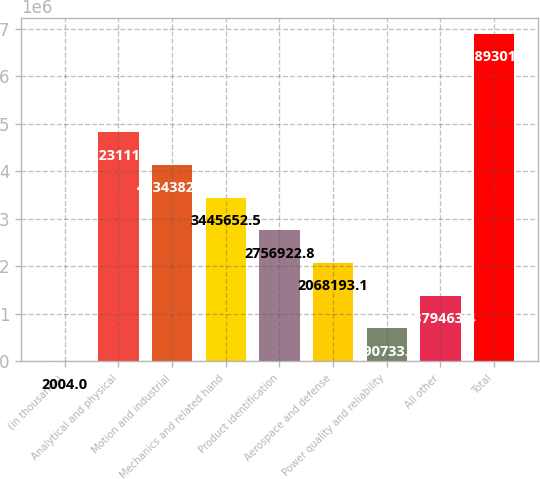Convert chart. <chart><loc_0><loc_0><loc_500><loc_500><bar_chart><fcel>(in thousands)<fcel>Analytical and physical<fcel>Motion and industrial<fcel>Mechanics and related hand<fcel>Product identification<fcel>Aerospace and defense<fcel>Power quality and reliability<fcel>All other<fcel>Total<nl><fcel>2004<fcel>4.82311e+06<fcel>4.13438e+06<fcel>3.44565e+06<fcel>2.75692e+06<fcel>2.06819e+06<fcel>690734<fcel>1.37946e+06<fcel>6.8893e+06<nl></chart> 